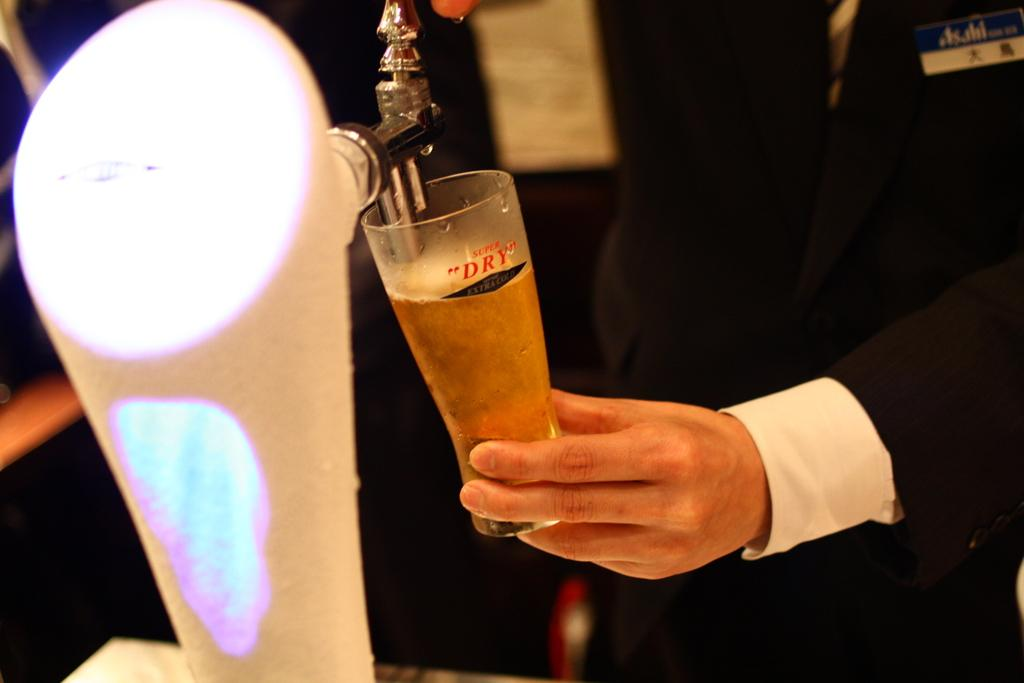Provide a one-sentence caption for the provided image. A man pull beer from a tap into a cup that says super dry. 